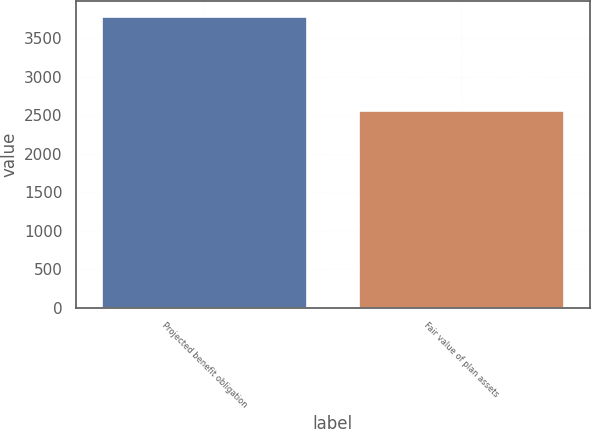Convert chart. <chart><loc_0><loc_0><loc_500><loc_500><bar_chart><fcel>Projected benefit obligation<fcel>Fair value of plan assets<nl><fcel>3793<fcel>2565<nl></chart> 